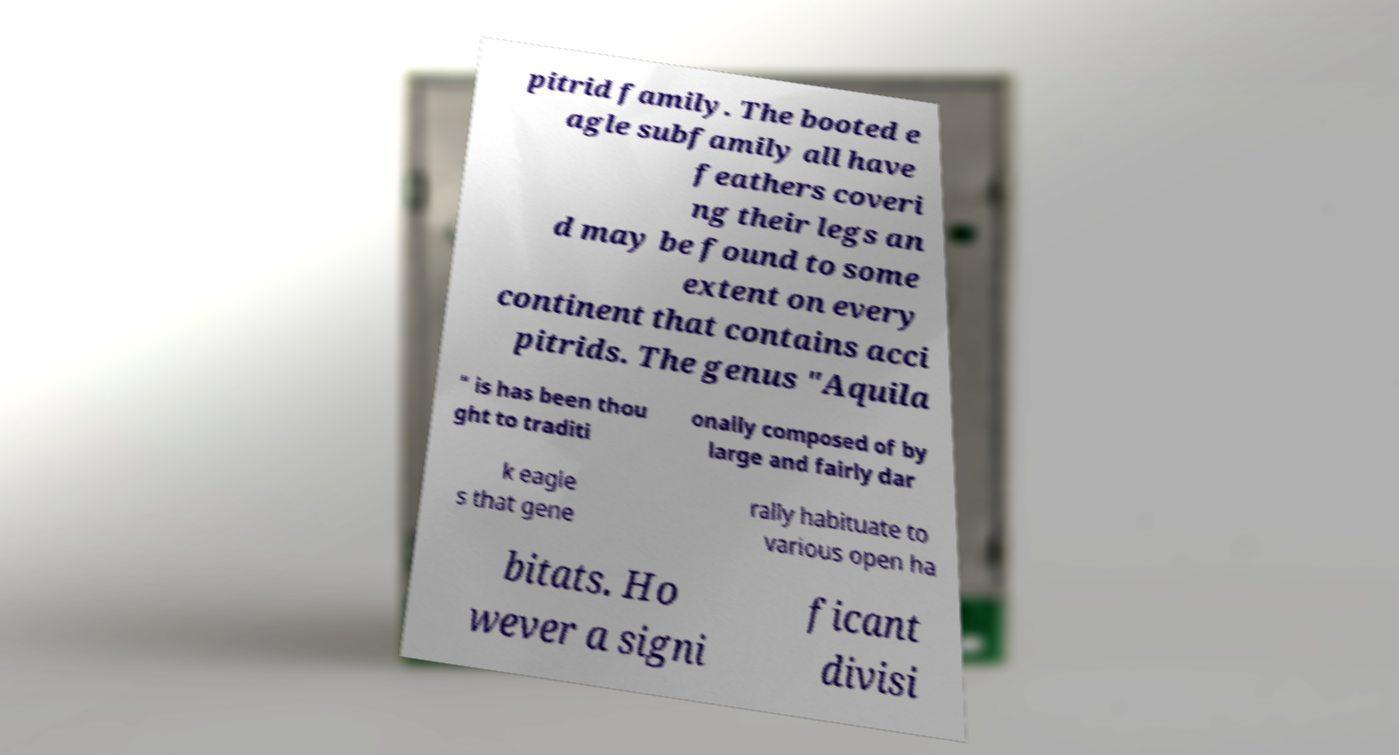Could you assist in decoding the text presented in this image and type it out clearly? pitrid family. The booted e agle subfamily all have feathers coveri ng their legs an d may be found to some extent on every continent that contains acci pitrids. The genus "Aquila " is has been thou ght to traditi onally composed of by large and fairly dar k eagle s that gene rally habituate to various open ha bitats. Ho wever a signi ficant divisi 